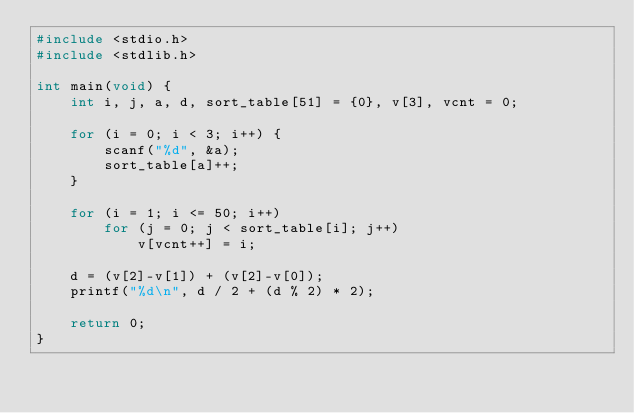<code> <loc_0><loc_0><loc_500><loc_500><_C_>#include <stdio.h>
#include <stdlib.h>

int main(void) {
	int i, j, a, d, sort_table[51] = {0}, v[3], vcnt = 0;
	
	for (i = 0; i < 3; i++) {
		scanf("%d", &a);
		sort_table[a]++;
	}
	
	for (i = 1; i <= 50; i++)
		for (j = 0; j < sort_table[i]; j++)
			v[vcnt++] = i;
	
	d = (v[2]-v[1]) + (v[2]-v[0]);
	printf("%d\n", d / 2 + (d % 2) * 2);
	
	return 0;
}</code> 